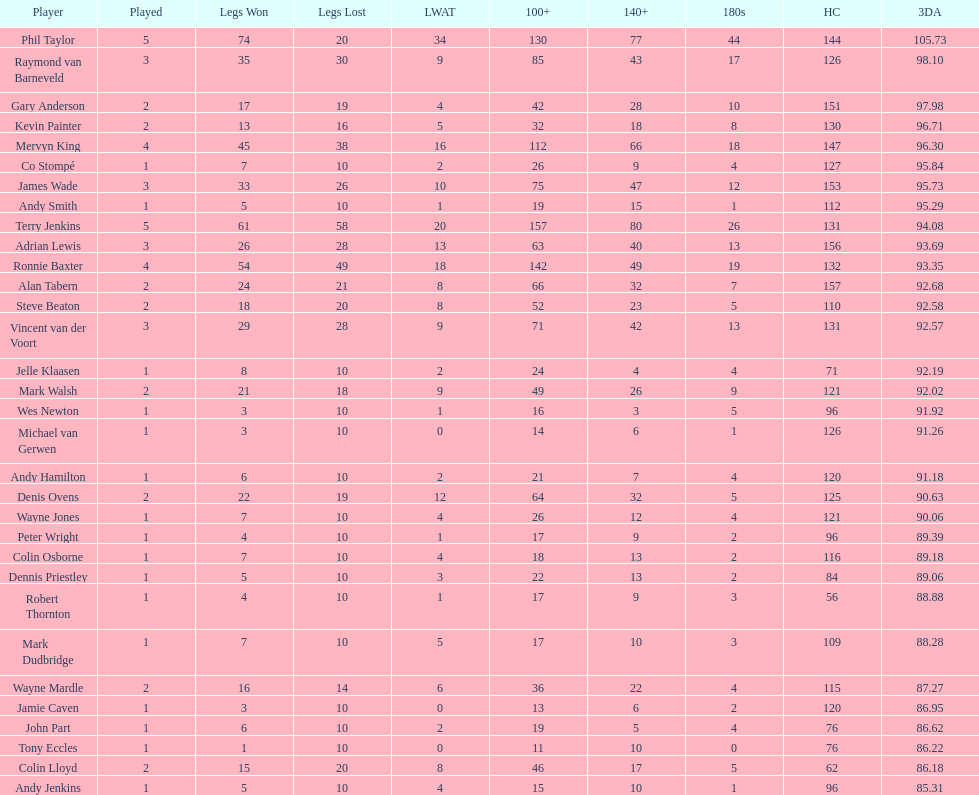What is the overall number of participants who have engaged in over three games? 4. 